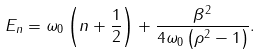<formula> <loc_0><loc_0><loc_500><loc_500>E _ { n } = \omega _ { 0 } \left ( n + \frac { 1 } { 2 } \right ) + \frac { \beta ^ { 2 } } { 4 \omega _ { 0 } \left ( \rho ^ { 2 } - 1 \right ) } .</formula> 